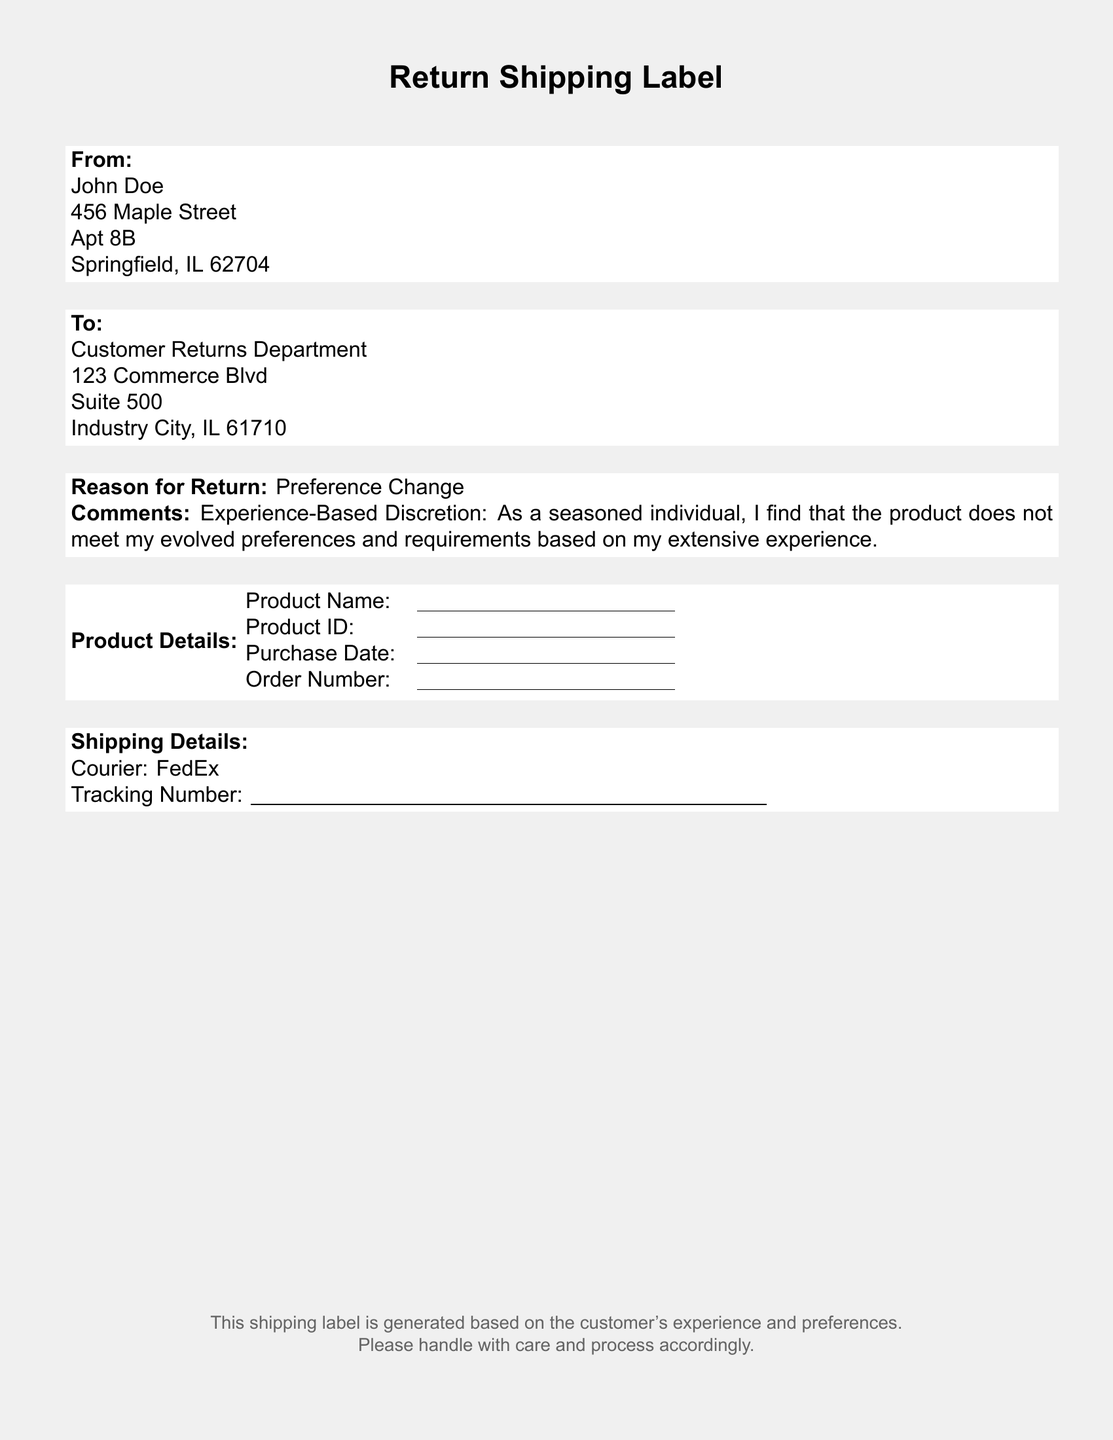what is the name of the sender? The sender's name is clearly stated at the top of the document under "From" section.
Answer: John Doe what is the address of the sender? The sender's address is listed in the "From" section of the document.
Answer: 456 Maple Street, Apt 8B, Springfield, IL 62704 what is the reason for return? The reason for return is specified in the identified section of the document.
Answer: Preference Change who is the recipient of the shipping label? The recipient is listed under the "To" section of the document, providing their department and address.
Answer: Customer Returns Department what is the product ID space in the document meant for? The space labeled Product ID is where the specific identification number of the product should be filled in.
Answer: \underline{\hspace{5cm}} what is mentioned under "Experience-Based Discretion"? This part contains a personal statement linking the individual’s experience to their decision regarding the product.
Answer: As a seasoned individual, I find that the product does not meet my evolved preferences and requirements based on my extensive experience what is the courier service mentioned? The name of the courier responsible for the return is clearly specified in the Shipping Details section.
Answer: FedEx what is included in the shipping details? The shipping details section contains information on the courier service and tracking number.
Answer: Courier: FedEx; Tracking Number: \underline{\hspace{10cm}} what kind of label is this document? The title at the top of the document identifies the type of document.
Answer: Return Shipping Label 